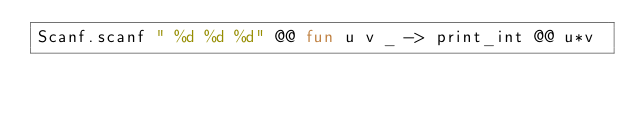<code> <loc_0><loc_0><loc_500><loc_500><_OCaml_>Scanf.scanf " %d %d %d" @@ fun u v _ -> print_int @@ u*v</code> 